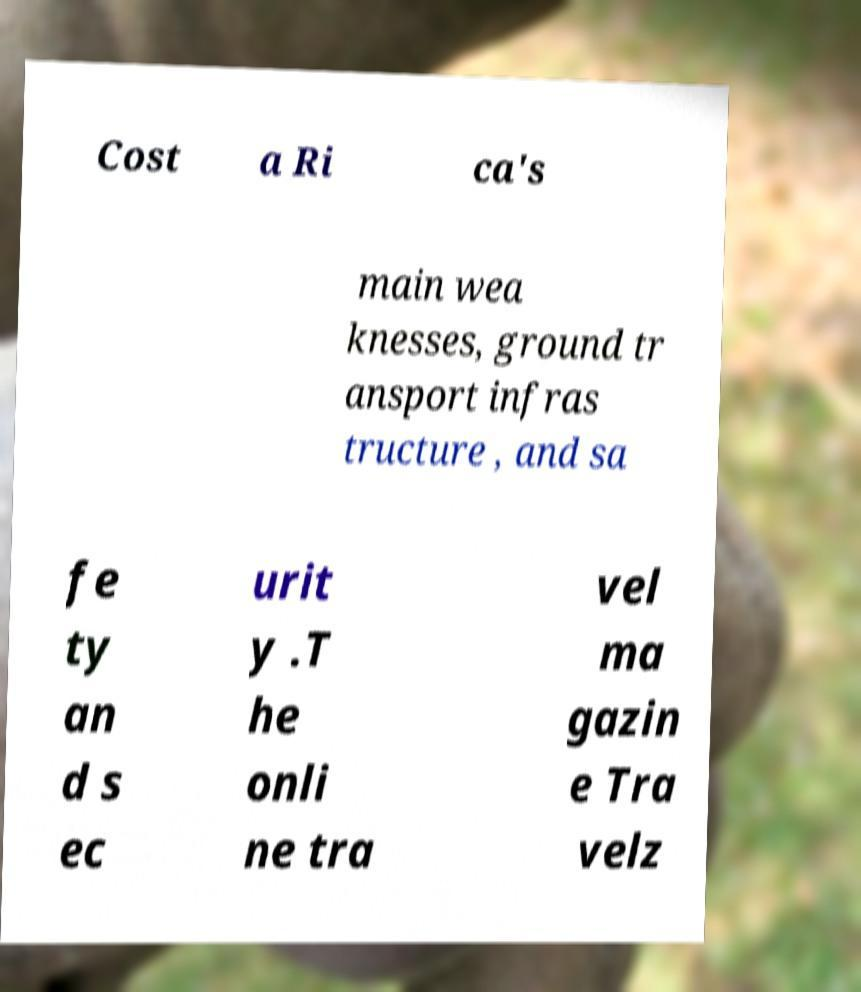For documentation purposes, I need the text within this image transcribed. Could you provide that? Cost a Ri ca's main wea knesses, ground tr ansport infras tructure , and sa fe ty an d s ec urit y .T he onli ne tra vel ma gazin e Tra velz 